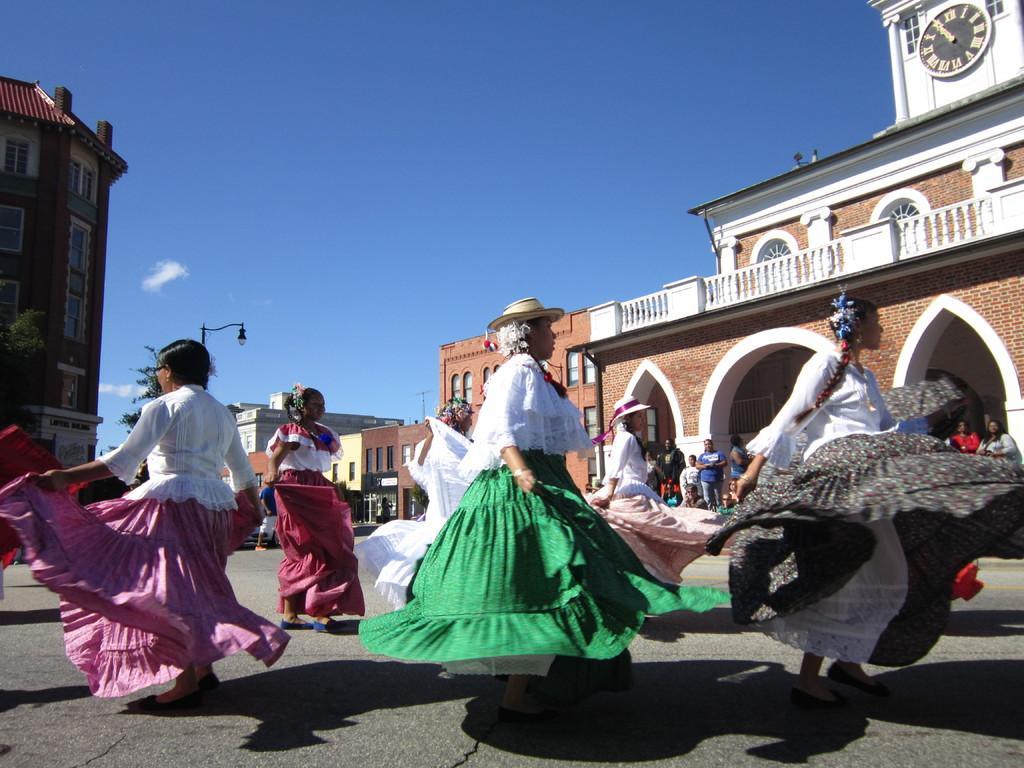In one or two sentences, can you explain what this image depicts? In this image we can see a few women dancing on the road, behind them there is a group of people standing and in the background there are buildings, street light, trees and there is a clock on a building which is on the right side of the image. 